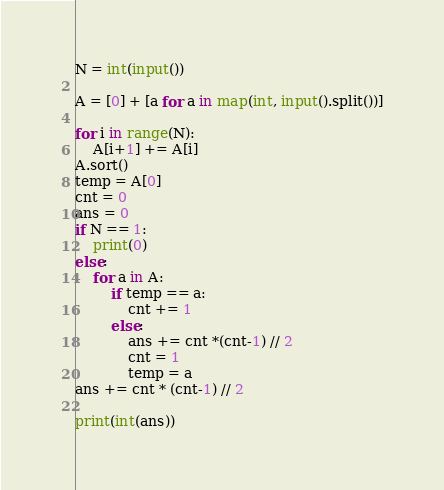Convert code to text. <code><loc_0><loc_0><loc_500><loc_500><_Python_>N = int(input())

A = [0] + [a for a in map(int, input().split())]

for i in range(N):
    A[i+1] += A[i]
A.sort()
temp = A[0]
cnt = 0
ans = 0
if N == 1:
    print(0)
else:
    for a in A:
        if temp == a:
            cnt += 1
        else:
            ans += cnt *(cnt-1) // 2
            cnt = 1
            temp = a
ans += cnt * (cnt-1) // 2

print(int(ans))
</code> 